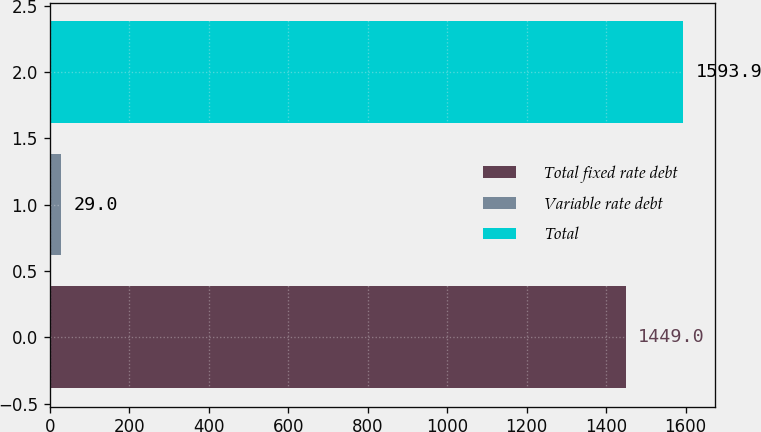Convert chart. <chart><loc_0><loc_0><loc_500><loc_500><bar_chart><fcel>Total fixed rate debt<fcel>Variable rate debt<fcel>Total<nl><fcel>1449<fcel>29<fcel>1593.9<nl></chart> 